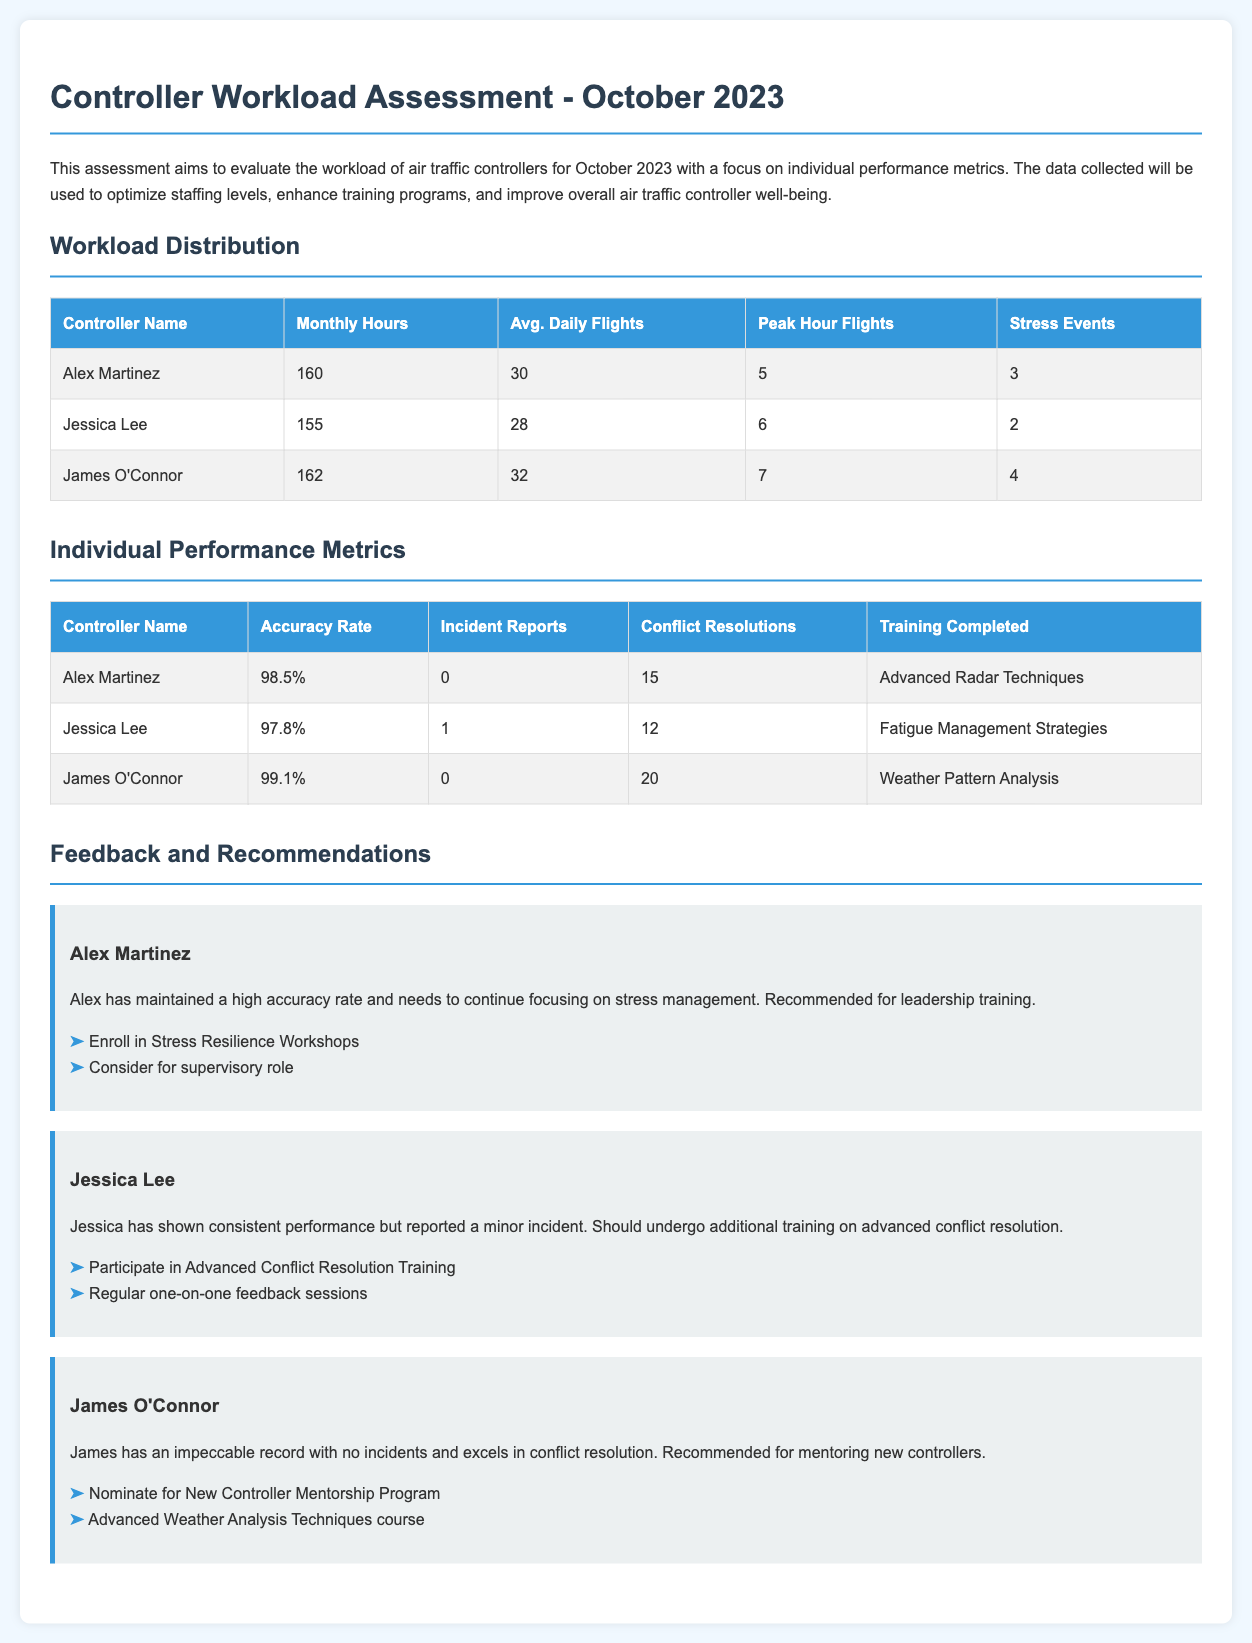What is the average daily flights for James O'Connor? The average daily flights for James O'Connor is specified in the Individual Performance Metrics section of the document.
Answer: 32 How many stress events did Jessica Lee report? The number of stress events reported by Jessica Lee is indicated in the Workload Distribution section of the document.
Answer: 2 Which training did Alex Martinez complete? The completed training for Alex Martinez is listed under Individual Performance Metrics in the document.
Answer: Advanced Radar Techniques What is the peak hour flights for Alex Martinez? The peak hour flights for Alex Martinez can be found in the Workload Distribution section of the document.
Answer: 5 Who has the highest accuracy rate? To determine who has the highest accuracy rate, we need to compare the accuracy rates listed in the Individual Performance Metrics table.
Answer: James O'Connor What recommendations were made for Jessica Lee? The recommendations for Jessica Lee are described in the Feedback and Recommendations section, specifically related to her performance.
Answer: Participate in Advanced Conflict Resolution Training How many conflict resolutions did James O'Connor achieve? The number of conflict resolutions for James O'Connor is provided in the Individual Performance Metrics section.
Answer: 20 What is the total monthly hours worked by Alex Martinez? The total monthly hours worked by Alex Martinez is presented in the Workload Distribution table.
Answer: 160 